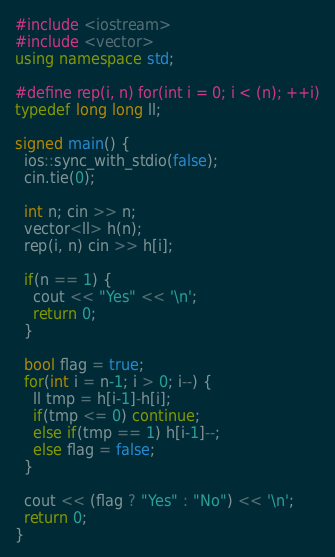Convert code to text. <code><loc_0><loc_0><loc_500><loc_500><_C++_>#include <iostream>
#include <vector>
using namespace std;

#define rep(i, n) for(int i = 0; i < (n); ++i)
typedef long long ll;

signed main() {
  ios::sync_with_stdio(false);
  cin.tie(0);

  int n; cin >> n;
  vector<ll> h(n);
  rep(i, n) cin >> h[i];

  if(n == 1) {
    cout << "Yes" << '\n';
    return 0;
  }

  bool flag = true;
  for(int i = n-1; i > 0; i--) {
    ll tmp = h[i-1]-h[i];
    if(tmp <= 0) continue;
    else if(tmp == 1) h[i-1]--;
    else flag = false;
  }

  cout << (flag ? "Yes" : "No") << '\n';
  return 0;
}
</code> 